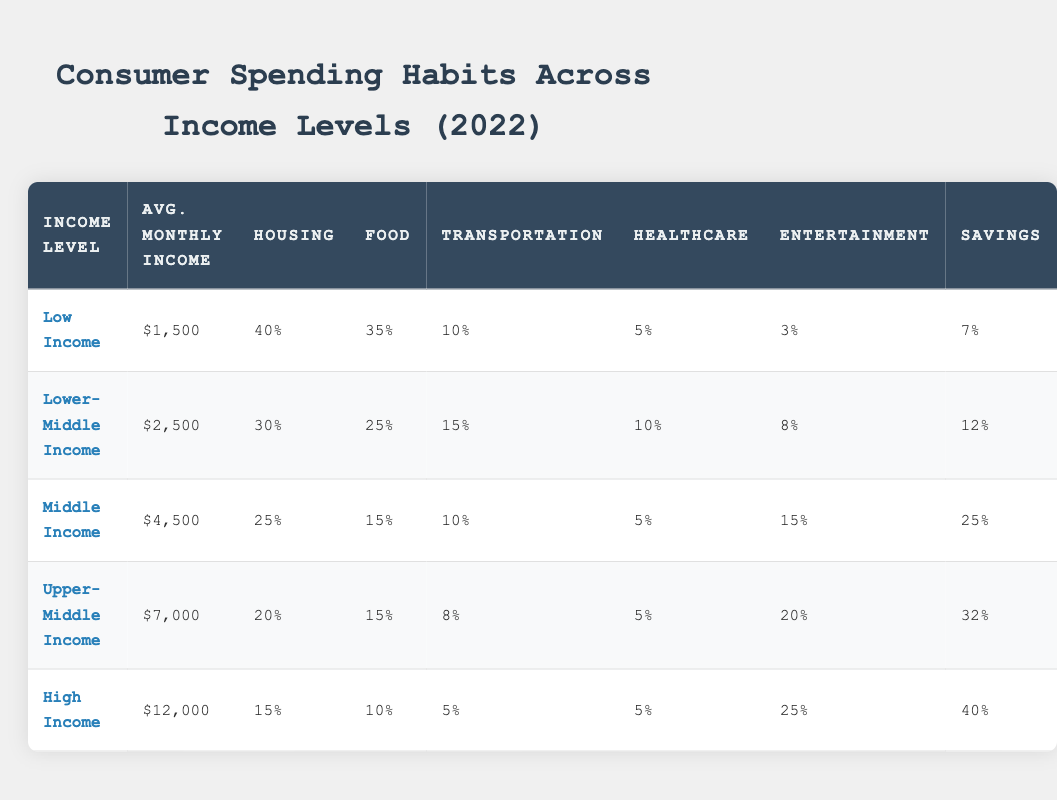What is the average monthly income for the Upper-Middle Income group? The table shows that the average monthly income for the Upper-Middle Income group is $7,000 as listed directly under the relevant column.
Answer: $7,000 Which income group allocates the highest percentage to entertainment? Looking at the entertainment percentage for each income level in the table, the High Income group allocates 25%, which is the highest percentage among all groups.
Answer: High Income What is the total percentage allocated to food and healthcare for Middle Income? For the Middle Income group, the percentage allocated to food is 15% and healthcare is 5%. Adding these together (15% + 5%) results in 20%.
Answer: 20% Is the savings percentage higher for Lower-Middle Income than for Low Income? The savings percentage for Lower-Middle Income is 12%, while for Low Income it is 7%. Therefore, 12% is greater than 7%, indicating it is true that the Lower-Middle Income group saves more.
Answer: Yes What is the difference in average monthly income between High Income and Low Income groups? The High Income group has an average monthly income of $12,000, and the Low Income group has $1,500. To find the difference, subtract the Low Income from High Income: $12,000 - $1,500 = $10,500.
Answer: $10,500 How much percentage of income does the Middle Income group save compared to the Upper-Middle Income group? The Middle Income group's savings percentage is 25%, while the Upper-Middle Income group's savings percentage is 32%. To find the percentage saved by the Middle Income group relative to the Upper-Middle Income group: 25% is less than 32%. Therefore, the Middle Income group saves less.
Answer: No What is the total percentage allocated to housing for all five income levels? From the table, the housing percentages are: 40% (Low Income), 30% (Lower-Middle), 25% (Middle Income), 20% (Upper-Middle), and 15% (High Income). Adding these provides the total: 40 + 30 + 25 + 20 + 15 = 130%.
Answer: 130% Which income level has the lowest percentage on transportation? Looking at the transportation percentages, the High Income group allocates only 5%, which is lower than all other income levels indicated in the table.
Answer: High Income What is the overall average percentage spent on food across all income levels? The percentages spent on food are: 35% (Low Income), 25% (Lower-Middle Income), 15% (Middle Income), 15% (Upper-Middle Income), and 10% (High Income). To find the average, sum them up (35 + 25 + 15 + 15 + 10 = 110) and divide by 5, giving an average of 22%.
Answer: 22% 